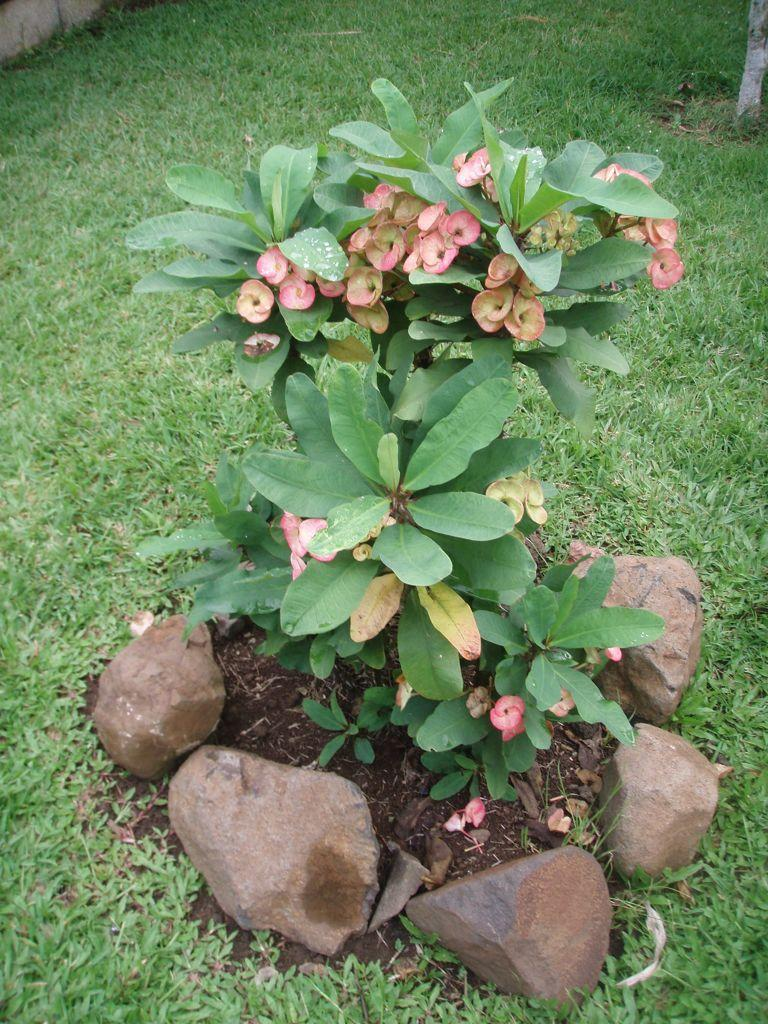What is located in the foreground of the image? There is a plant in the foreground of the image. What can be seen on the plant? The plant has flowers on it. What type of material is visible on the ground around the plant? There are stones visible on the ground around the plant. Where is the lunchroom located in the image? There is no mention of a lunchroom in the image; it only describes a plant with flowers and stones on the ground. Can you tell me how many rats are visible in the image? There are no rats mentioned or visible in the image. 